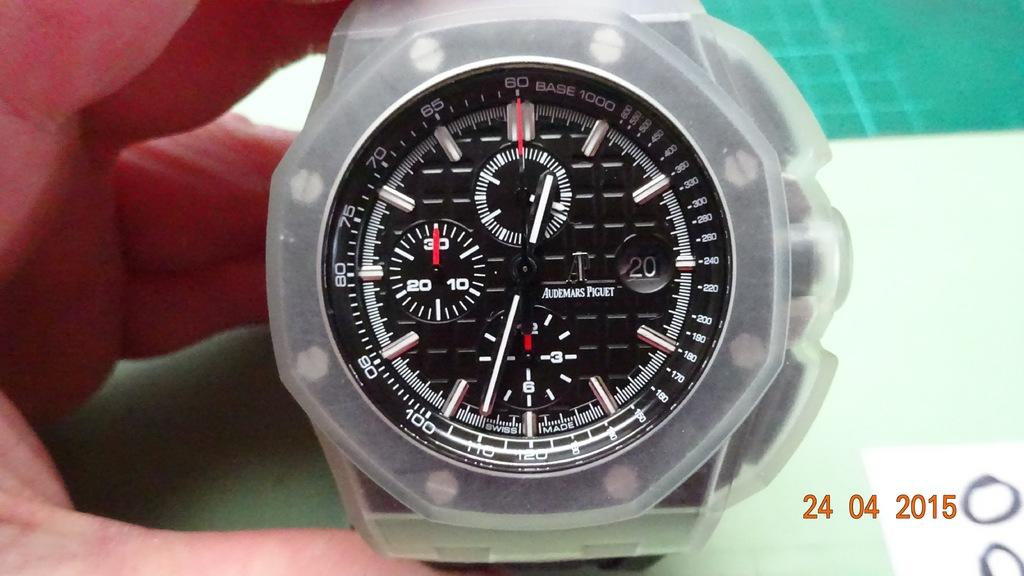Provide a one-sentence caption for the provided image. Person holding a stopwatch which says Audemars Piguet on the face. 